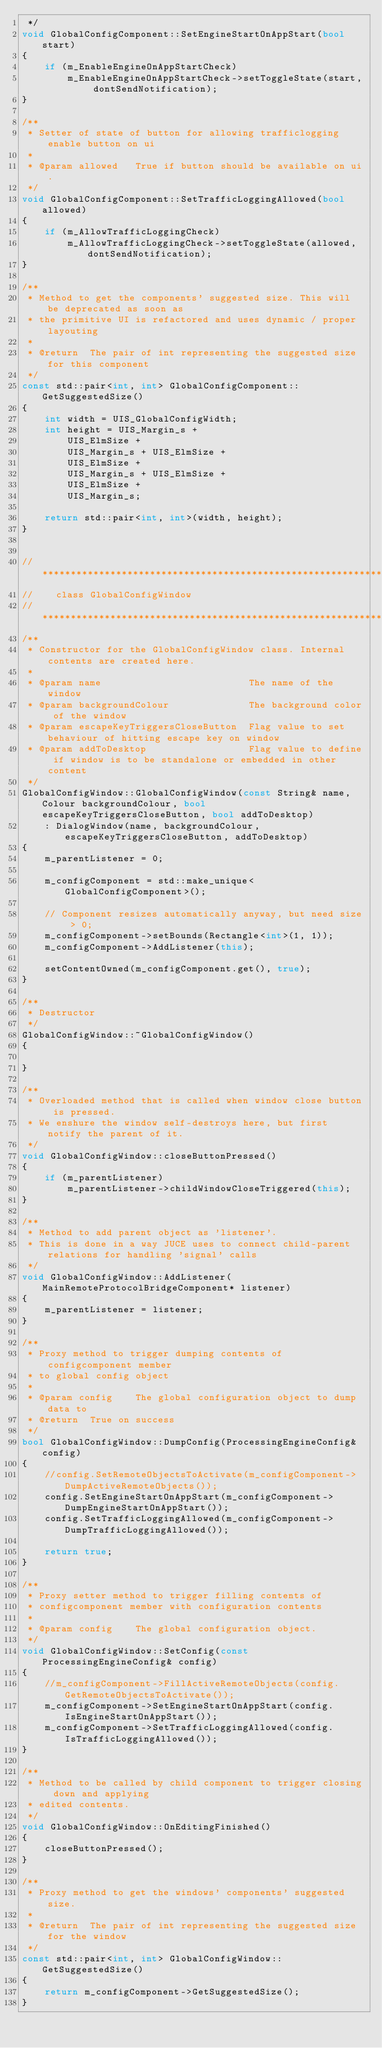Convert code to text. <code><loc_0><loc_0><loc_500><loc_500><_C++_> */
void GlobalConfigComponent::SetEngineStartOnAppStart(bool start)
{
	if (m_EnableEngineOnAppStartCheck)
		m_EnableEngineOnAppStartCheck->setToggleState(start, dontSendNotification);
}

/**
 * Setter of state of button for allowing trafficlogging enable button on ui
 *
 * @param allowed	True if button should be available on ui.
 */
void GlobalConfigComponent::SetTrafficLoggingAllowed(bool allowed)
{
	if (m_AllowTrafficLoggingCheck)
		m_AllowTrafficLoggingCheck->setToggleState(allowed, dontSendNotification);
}

/**
 * Method to get the components' suggested size. This will be deprecated as soon as
 * the primitive UI is refactored and uses dynamic / proper layouting
 *
 * @return	The pair of int representing the suggested size for this component
 */
const std::pair<int, int> GlobalConfigComponent::GetSuggestedSize()
{
	int width = UIS_GlobalConfigWidth;
	int height = UIS_Margin_s +
		UIS_ElmSize +
		UIS_Margin_s + UIS_ElmSize +
		UIS_ElmSize +
		UIS_Margin_s + UIS_ElmSize +
		UIS_ElmSize +
		UIS_Margin_s;

	return std::pair<int, int>(width, height);
}


// **************************************************************************************
//    class GlobalConfigWindow
// **************************************************************************************
/**
 * Constructor for the GlobalConfigWindow class. Internal contents are created here.
 *
 * @param name							The name of the window
 * @param backgroundColour				The background color of the window
 * @param escapeKeyTriggersCloseButton	Flag value to set behaviour of hitting escape key on window
 * @param addToDesktop					Flag value to define if window is to be standalone or embedded in other content
 */
GlobalConfigWindow::GlobalConfigWindow(const String& name, Colour backgroundColour, bool escapeKeyTriggersCloseButton, bool addToDesktop)
	: DialogWindow(name, backgroundColour, escapeKeyTriggersCloseButton, addToDesktop)
{
	m_parentListener = 0;

	m_configComponent = std::make_unique<GlobalConfigComponent>();
	
	// Component resizes automatically anyway, but need size > 0;
	m_configComponent->setBounds(Rectangle<int>(1, 1));
	m_configComponent->AddListener(this);
	
	setContentOwned(m_configComponent.get(), true);
}

/**
 * Destructor
 */
GlobalConfigWindow::~GlobalConfigWindow()
{

}

/**
 * Overloaded method that is called when window close button is pressed.
 * We enshure the window self-destroys here, but first notify the parent of it.
 */
void GlobalConfigWindow::closeButtonPressed()
{
	if (m_parentListener)
		m_parentListener->childWindowCloseTriggered(this);
}

/**
 * Method to add parent object as 'listener'.
 * This is done in a way JUCE uses to connect child-parent relations for handling 'signal' calls
 */
void GlobalConfigWindow::AddListener(MainRemoteProtocolBridgeComponent* listener)
{
	m_parentListener = listener;
}

/**
 * Proxy method to trigger dumping contents of configcomponent member
 * to global config object
 *
 * @param config	The global configuration object to dump data to
 * @return	True on success
 */
bool GlobalConfigWindow::DumpConfig(ProcessingEngineConfig& config)
{
	//config.SetRemoteObjectsToActivate(m_configComponent->DumpActiveRemoteObjects());
	config.SetEngineStartOnAppStart(m_configComponent->DumpEngineStartOnAppStart());
	config.SetTrafficLoggingAllowed(m_configComponent->DumpTrafficLoggingAllowed());

	return true;
}

/**
 * Proxy setter method to trigger filling contents of
 * configcomponent member with configuration contents
 *
 * @param config	The global configuration object.
 */
void GlobalConfigWindow::SetConfig(const ProcessingEngineConfig& config)
{
	//m_configComponent->FillActiveRemoteObjects(config.GetRemoteObjectsToActivate());
	m_configComponent->SetEngineStartOnAppStart(config.IsEngineStartOnAppStart());
	m_configComponent->SetTrafficLoggingAllowed(config.IsTrafficLoggingAllowed());
}

/**
 * Method to be called by child component to trigger closing down and applying
 * edited contents.
 */
void GlobalConfigWindow::OnEditingFinished()
{
	closeButtonPressed();
}

/**
 * Proxy method to get the windows' components' suggested size.
 *
 * @return	The pair of int representing the suggested size for the window
 */
const std::pair<int, int> GlobalConfigWindow::GetSuggestedSize()
{
	return m_configComponent->GetSuggestedSize();
}
</code> 